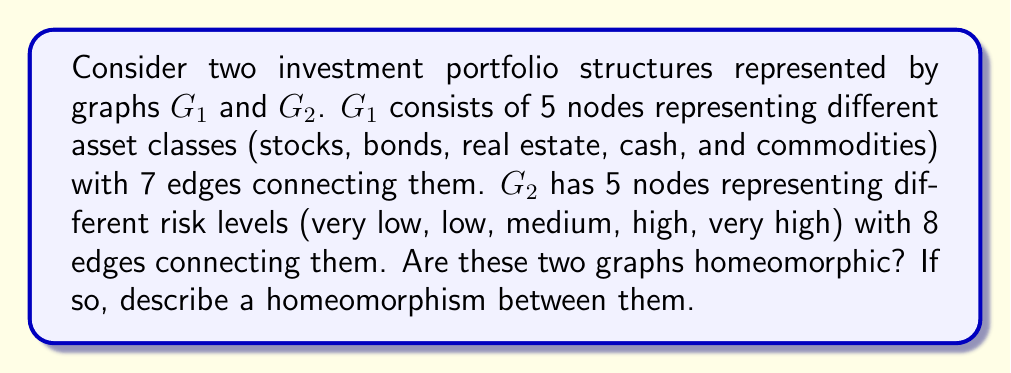Provide a solution to this math problem. To determine if the two graphs $G_1$ and $G_2$ are homeomorphic, we need to analyze their topological properties:

1. Number of vertices: Both graphs have 5 vertices, which is a necessary condition for homeomorphism.

2. Connectivity: We need to check if both graphs are connected. Given that $G_1$ has 5 vertices and 7 edges, and $G_2$ has 5 vertices and 8 edges, both graphs are connected (the minimum number of edges needed to connect 5 vertices is 4).

3. Cycles: We need to determine the number of independent cycles in each graph.

   For $G_1$: Number of cycles = Edges - Vertices + 1 = 7 - 5 + 1 = 3
   For $G_2$: Number of cycles = Edges - Vertices + 1 = 8 - 5 + 1 = 4

Since the number of independent cycles is different for $G_1$ and $G_2$, they are not homeomorphic.

In the context of investment portfolios:
- $G_1$ represents a portfolio structure where asset classes are interconnected, but with some flexibility in allocation.
- $G_2$ represents a risk-based portfolio structure with more interconnections between risk levels, allowing for smoother transitions between risk categories.

Although these structures are not homeomorphic, they both offer valid approaches to portfolio management. The choice between them would depend on whether the investor (in this case, the freelance graphic designer) prefers to focus on asset allocation or risk management in their retirement savings strategy.
Answer: The graphs $G_1$ and $G_2$ are not homeomorphic, as they have a different number of independent cycles (3 for $G_1$ and 4 for $G_2$). 